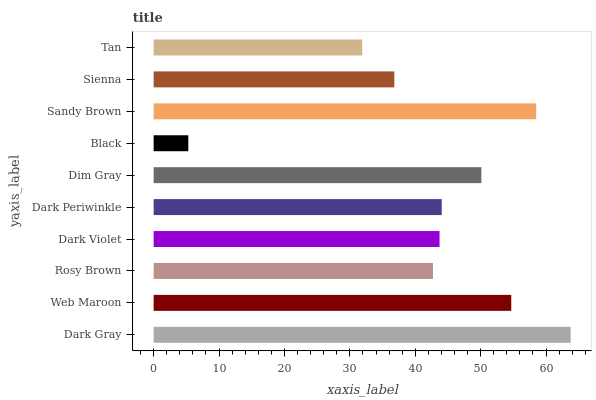Is Black the minimum?
Answer yes or no. Yes. Is Dark Gray the maximum?
Answer yes or no. Yes. Is Web Maroon the minimum?
Answer yes or no. No. Is Web Maroon the maximum?
Answer yes or no. No. Is Dark Gray greater than Web Maroon?
Answer yes or no. Yes. Is Web Maroon less than Dark Gray?
Answer yes or no. Yes. Is Web Maroon greater than Dark Gray?
Answer yes or no. No. Is Dark Gray less than Web Maroon?
Answer yes or no. No. Is Dark Periwinkle the high median?
Answer yes or no. Yes. Is Dark Violet the low median?
Answer yes or no. Yes. Is Sandy Brown the high median?
Answer yes or no. No. Is Dark Gray the low median?
Answer yes or no. No. 